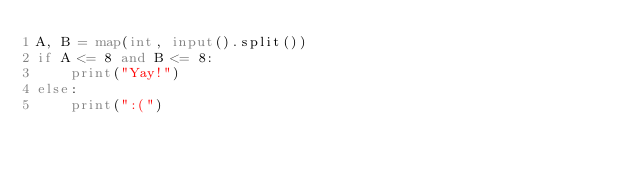<code> <loc_0><loc_0><loc_500><loc_500><_Python_>A, B = map(int, input().split())
if A <= 8 and B <= 8:
    print("Yay!")
else:
    print(":(")
</code> 